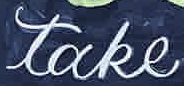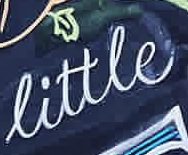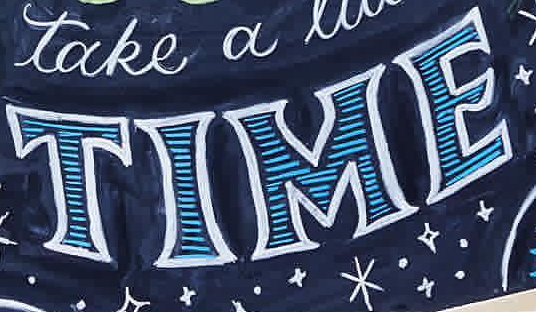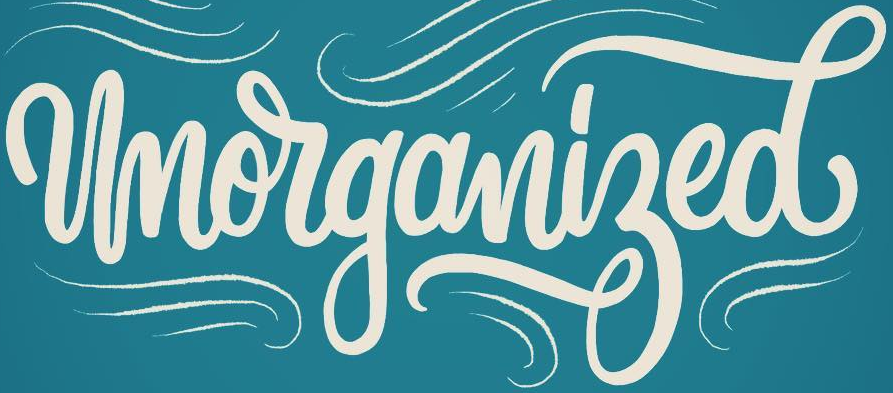Identify the words shown in these images in order, separated by a semicolon. take; little; TIME; Unorganized 